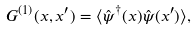<formula> <loc_0><loc_0><loc_500><loc_500>G ^ { ( 1 ) } ( x , x ^ { \prime } ) = \langle \hat { \psi } ^ { \dagger } ( x ) \hat { \psi } ( x ^ { \prime } ) \rangle ,</formula> 